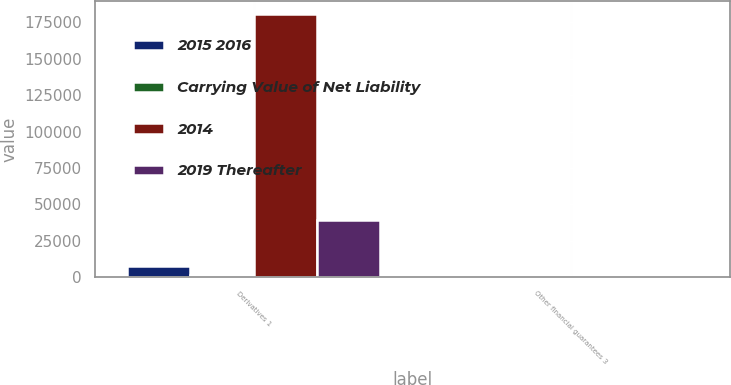<chart> <loc_0><loc_0><loc_500><loc_500><stacked_bar_chart><ecel><fcel>Derivatives 1<fcel>Other financial guarantees 3<nl><fcel>2015 2016<fcel>7634<fcel>213<nl><fcel>Carrying Value of Net Liability<fcel>1361<fcel>1361<nl><fcel>2014<fcel>180543<fcel>620<nl><fcel>2019 Thereafter<fcel>39367<fcel>1140<nl></chart> 